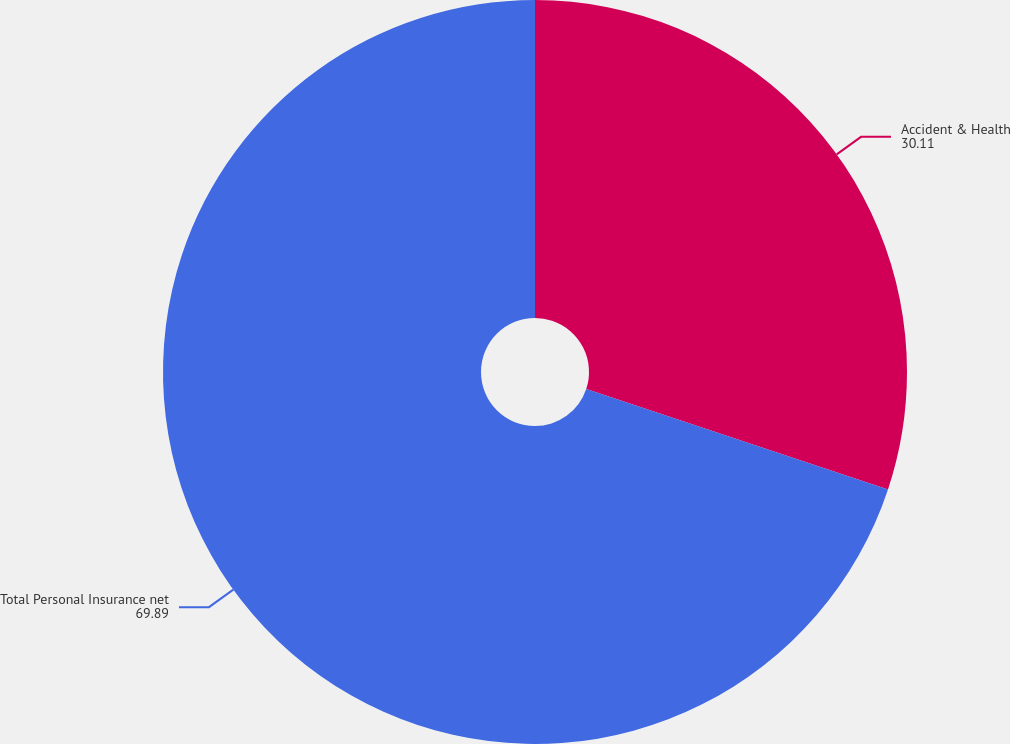Convert chart. <chart><loc_0><loc_0><loc_500><loc_500><pie_chart><fcel>Accident & Health<fcel>Total Personal Insurance net<nl><fcel>30.11%<fcel>69.89%<nl></chart> 